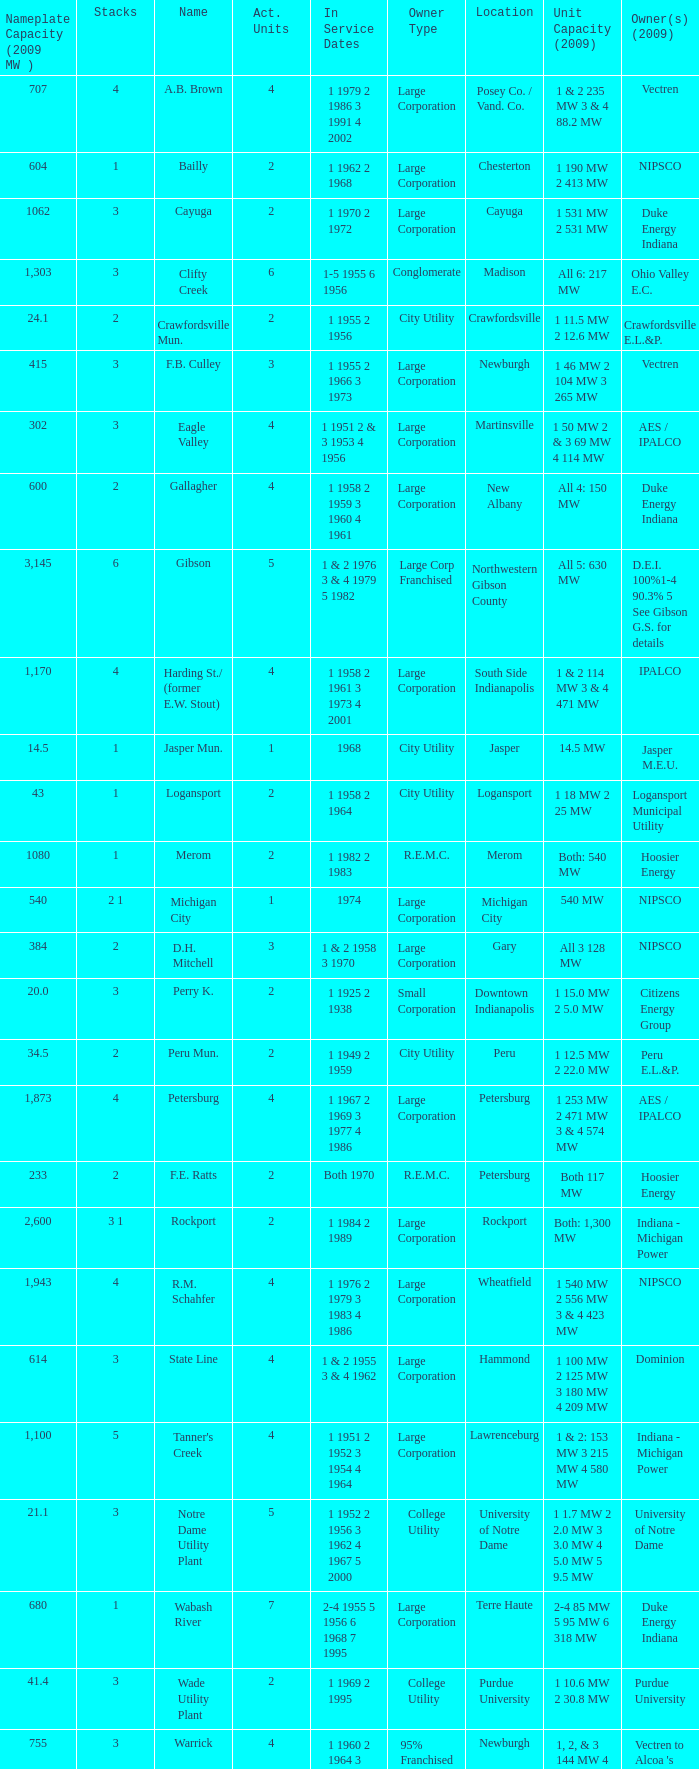How many stacks are there for 1 & 2 with 235 mw capacity and 3 & 4 with 88.2 mw capacity? 1.0. 